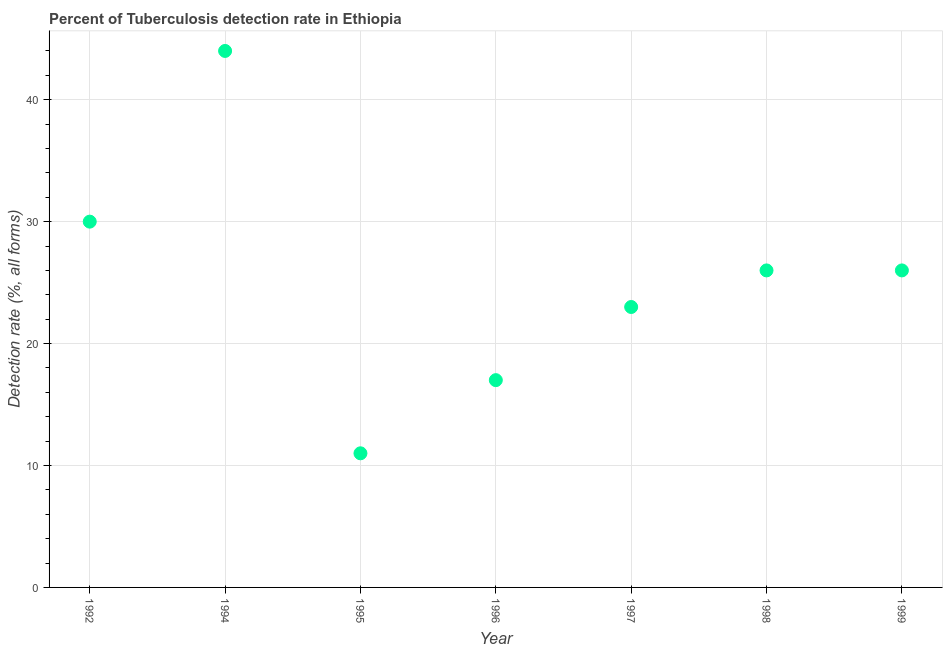What is the detection rate of tuberculosis in 1996?
Your answer should be very brief. 17. Across all years, what is the maximum detection rate of tuberculosis?
Provide a succinct answer. 44. Across all years, what is the minimum detection rate of tuberculosis?
Make the answer very short. 11. What is the sum of the detection rate of tuberculosis?
Provide a succinct answer. 177. What is the difference between the detection rate of tuberculosis in 1997 and 1998?
Offer a very short reply. -3. What is the average detection rate of tuberculosis per year?
Ensure brevity in your answer.  25.29. What is the ratio of the detection rate of tuberculosis in 1994 to that in 1998?
Give a very brief answer. 1.69. Is the detection rate of tuberculosis in 1996 less than that in 1998?
Provide a succinct answer. Yes. Is the difference between the detection rate of tuberculosis in 1992 and 1994 greater than the difference between any two years?
Your response must be concise. No. What is the difference between the highest and the second highest detection rate of tuberculosis?
Your answer should be compact. 14. What is the difference between the highest and the lowest detection rate of tuberculosis?
Your answer should be very brief. 33. Does the detection rate of tuberculosis monotonically increase over the years?
Your response must be concise. No. How many dotlines are there?
Make the answer very short. 1. What is the difference between two consecutive major ticks on the Y-axis?
Offer a terse response. 10. Are the values on the major ticks of Y-axis written in scientific E-notation?
Offer a terse response. No. Does the graph contain grids?
Offer a terse response. Yes. What is the title of the graph?
Give a very brief answer. Percent of Tuberculosis detection rate in Ethiopia. What is the label or title of the X-axis?
Ensure brevity in your answer.  Year. What is the label or title of the Y-axis?
Provide a short and direct response. Detection rate (%, all forms). What is the Detection rate (%, all forms) in 1992?
Your answer should be very brief. 30. What is the Detection rate (%, all forms) in 1994?
Your answer should be compact. 44. What is the Detection rate (%, all forms) in 1995?
Give a very brief answer. 11. What is the Detection rate (%, all forms) in 1997?
Give a very brief answer. 23. What is the Detection rate (%, all forms) in 1999?
Give a very brief answer. 26. What is the difference between the Detection rate (%, all forms) in 1992 and 1994?
Your answer should be very brief. -14. What is the difference between the Detection rate (%, all forms) in 1992 and 1996?
Keep it short and to the point. 13. What is the difference between the Detection rate (%, all forms) in 1994 and 1997?
Offer a very short reply. 21. What is the difference between the Detection rate (%, all forms) in 1994 and 1998?
Your answer should be compact. 18. What is the difference between the Detection rate (%, all forms) in 1994 and 1999?
Ensure brevity in your answer.  18. What is the difference between the Detection rate (%, all forms) in 1995 and 1996?
Provide a short and direct response. -6. What is the difference between the Detection rate (%, all forms) in 1995 and 1998?
Your answer should be very brief. -15. What is the difference between the Detection rate (%, all forms) in 1996 and 1997?
Make the answer very short. -6. What is the difference between the Detection rate (%, all forms) in 1996 and 1998?
Offer a terse response. -9. What is the difference between the Detection rate (%, all forms) in 1997 and 1998?
Provide a short and direct response. -3. What is the difference between the Detection rate (%, all forms) in 1998 and 1999?
Keep it short and to the point. 0. What is the ratio of the Detection rate (%, all forms) in 1992 to that in 1994?
Provide a succinct answer. 0.68. What is the ratio of the Detection rate (%, all forms) in 1992 to that in 1995?
Offer a very short reply. 2.73. What is the ratio of the Detection rate (%, all forms) in 1992 to that in 1996?
Your answer should be very brief. 1.76. What is the ratio of the Detection rate (%, all forms) in 1992 to that in 1997?
Offer a terse response. 1.3. What is the ratio of the Detection rate (%, all forms) in 1992 to that in 1998?
Your answer should be compact. 1.15. What is the ratio of the Detection rate (%, all forms) in 1992 to that in 1999?
Offer a terse response. 1.15. What is the ratio of the Detection rate (%, all forms) in 1994 to that in 1996?
Your answer should be compact. 2.59. What is the ratio of the Detection rate (%, all forms) in 1994 to that in 1997?
Give a very brief answer. 1.91. What is the ratio of the Detection rate (%, all forms) in 1994 to that in 1998?
Offer a terse response. 1.69. What is the ratio of the Detection rate (%, all forms) in 1994 to that in 1999?
Provide a short and direct response. 1.69. What is the ratio of the Detection rate (%, all forms) in 1995 to that in 1996?
Your answer should be very brief. 0.65. What is the ratio of the Detection rate (%, all forms) in 1995 to that in 1997?
Your answer should be compact. 0.48. What is the ratio of the Detection rate (%, all forms) in 1995 to that in 1998?
Make the answer very short. 0.42. What is the ratio of the Detection rate (%, all forms) in 1995 to that in 1999?
Provide a succinct answer. 0.42. What is the ratio of the Detection rate (%, all forms) in 1996 to that in 1997?
Make the answer very short. 0.74. What is the ratio of the Detection rate (%, all forms) in 1996 to that in 1998?
Offer a terse response. 0.65. What is the ratio of the Detection rate (%, all forms) in 1996 to that in 1999?
Ensure brevity in your answer.  0.65. What is the ratio of the Detection rate (%, all forms) in 1997 to that in 1998?
Make the answer very short. 0.89. What is the ratio of the Detection rate (%, all forms) in 1997 to that in 1999?
Give a very brief answer. 0.89. What is the ratio of the Detection rate (%, all forms) in 1998 to that in 1999?
Provide a succinct answer. 1. 